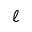<formula> <loc_0><loc_0><loc_500><loc_500>\ell</formula> 